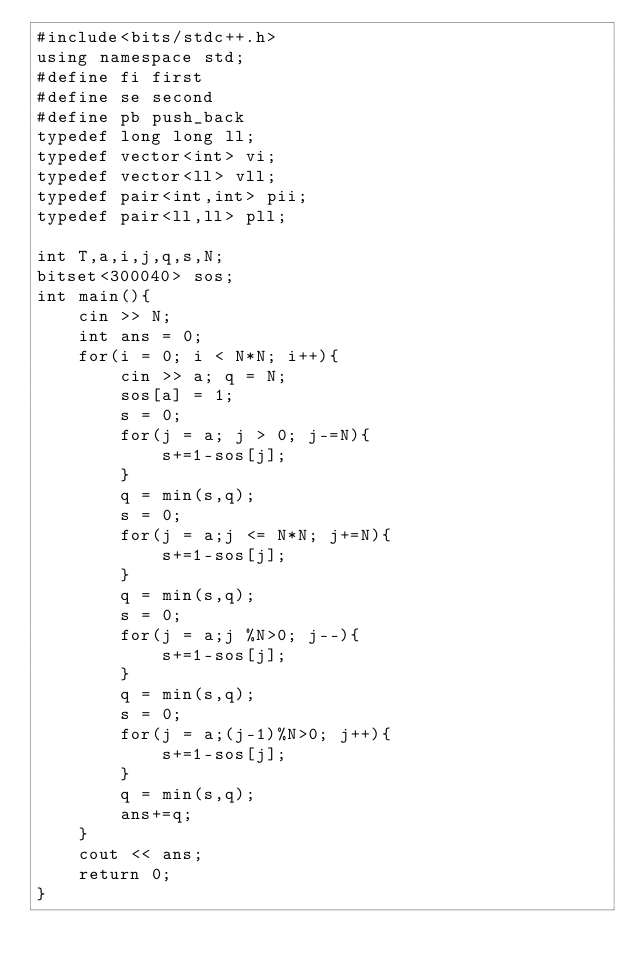<code> <loc_0><loc_0><loc_500><loc_500><_C++_>#include<bits/stdc++.h>
using namespace std;
#define fi first
#define se second
#define pb push_back
typedef long long ll;
typedef vector<int> vi;
typedef vector<ll> vll;
typedef pair<int,int> pii;
typedef pair<ll,ll> pll;

int T,a,i,j,q,s,N;
bitset<300040> sos;
int main(){
    cin >> N;
    int ans = 0;
    for(i = 0; i < N*N; i++){
        cin >> a; q = N;
        sos[a] = 1;
        s = 0;
        for(j = a; j > 0; j-=N){
            s+=1-sos[j];
        }
        q = min(s,q);
        s = 0;
        for(j = a;j <= N*N; j+=N){
            s+=1-sos[j];
        }
        q = min(s,q);
        s = 0;
        for(j = a;j %N>0; j--){
            s+=1-sos[j];
        }
        q = min(s,q);
        s = 0;
        for(j = a;(j-1)%N>0; j++){
            s+=1-sos[j];
        }
        q = min(s,q);
        ans+=q;
    }
    cout << ans;
    return 0;
}
</code> 